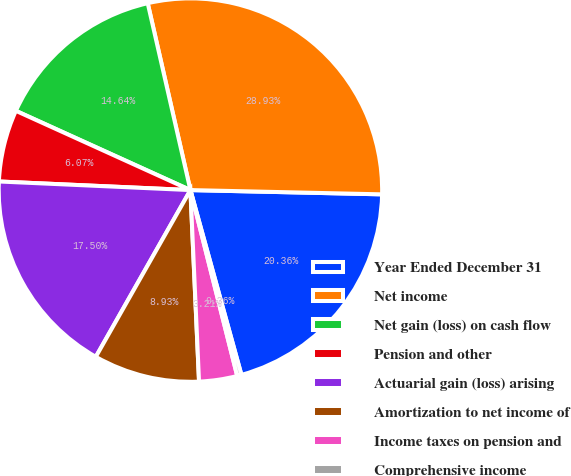<chart> <loc_0><loc_0><loc_500><loc_500><pie_chart><fcel>Year Ended December 31<fcel>Net income<fcel>Net gain (loss) on cash flow<fcel>Pension and other<fcel>Actuarial gain (loss) arising<fcel>Amortization to net income of<fcel>Income taxes on pension and<fcel>Comprehensive income<nl><fcel>20.36%<fcel>28.93%<fcel>14.64%<fcel>6.07%<fcel>17.5%<fcel>8.93%<fcel>3.21%<fcel>0.36%<nl></chart> 